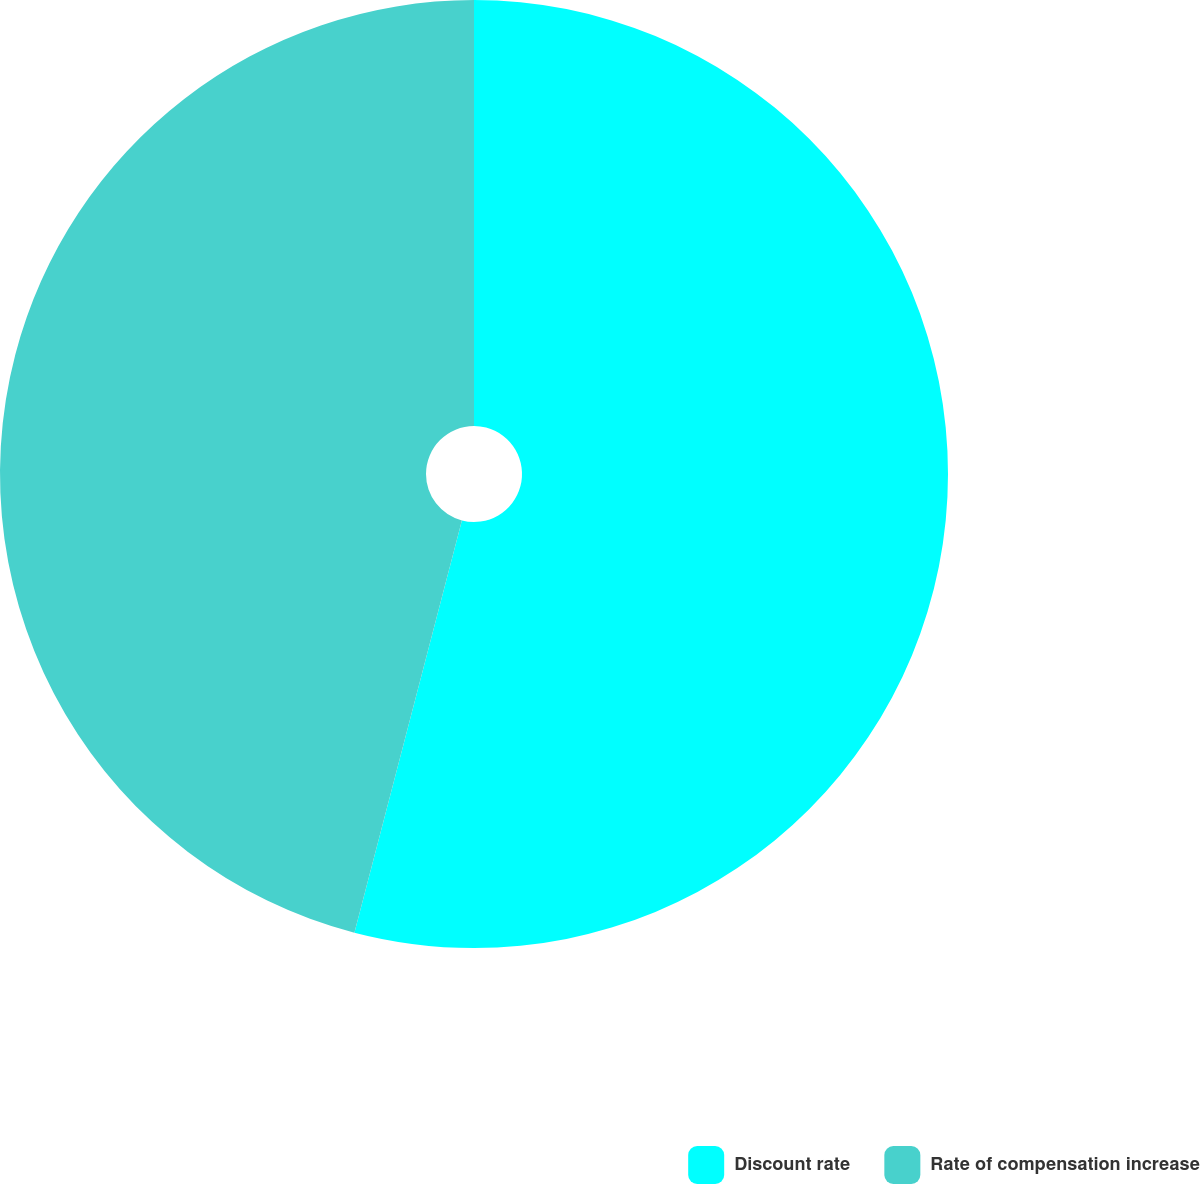Convert chart. <chart><loc_0><loc_0><loc_500><loc_500><pie_chart><fcel>Discount rate<fcel>Rate of compensation increase<nl><fcel>54.06%<fcel>45.94%<nl></chart> 